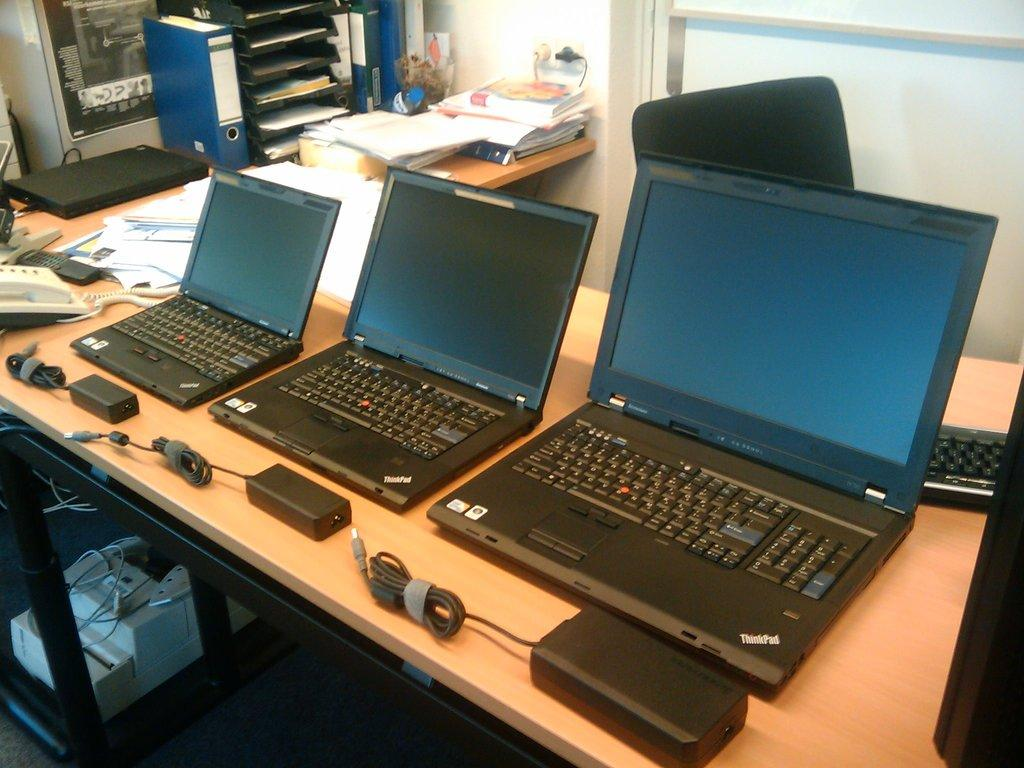<image>
Share a concise interpretation of the image provided. Three Think Pad laptops are on a desk next to each other. 